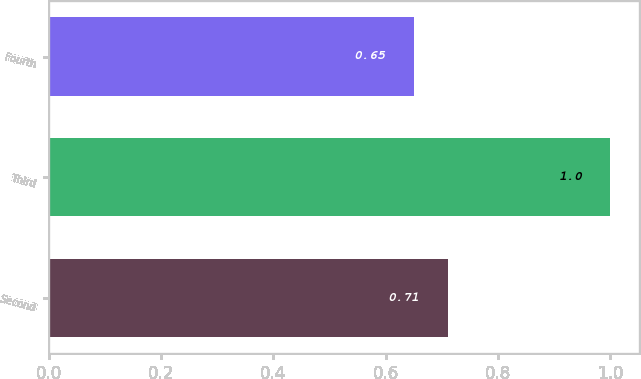Convert chart. <chart><loc_0><loc_0><loc_500><loc_500><bar_chart><fcel>Second<fcel>Third<fcel>Fourth<nl><fcel>0.71<fcel>1<fcel>0.65<nl></chart> 